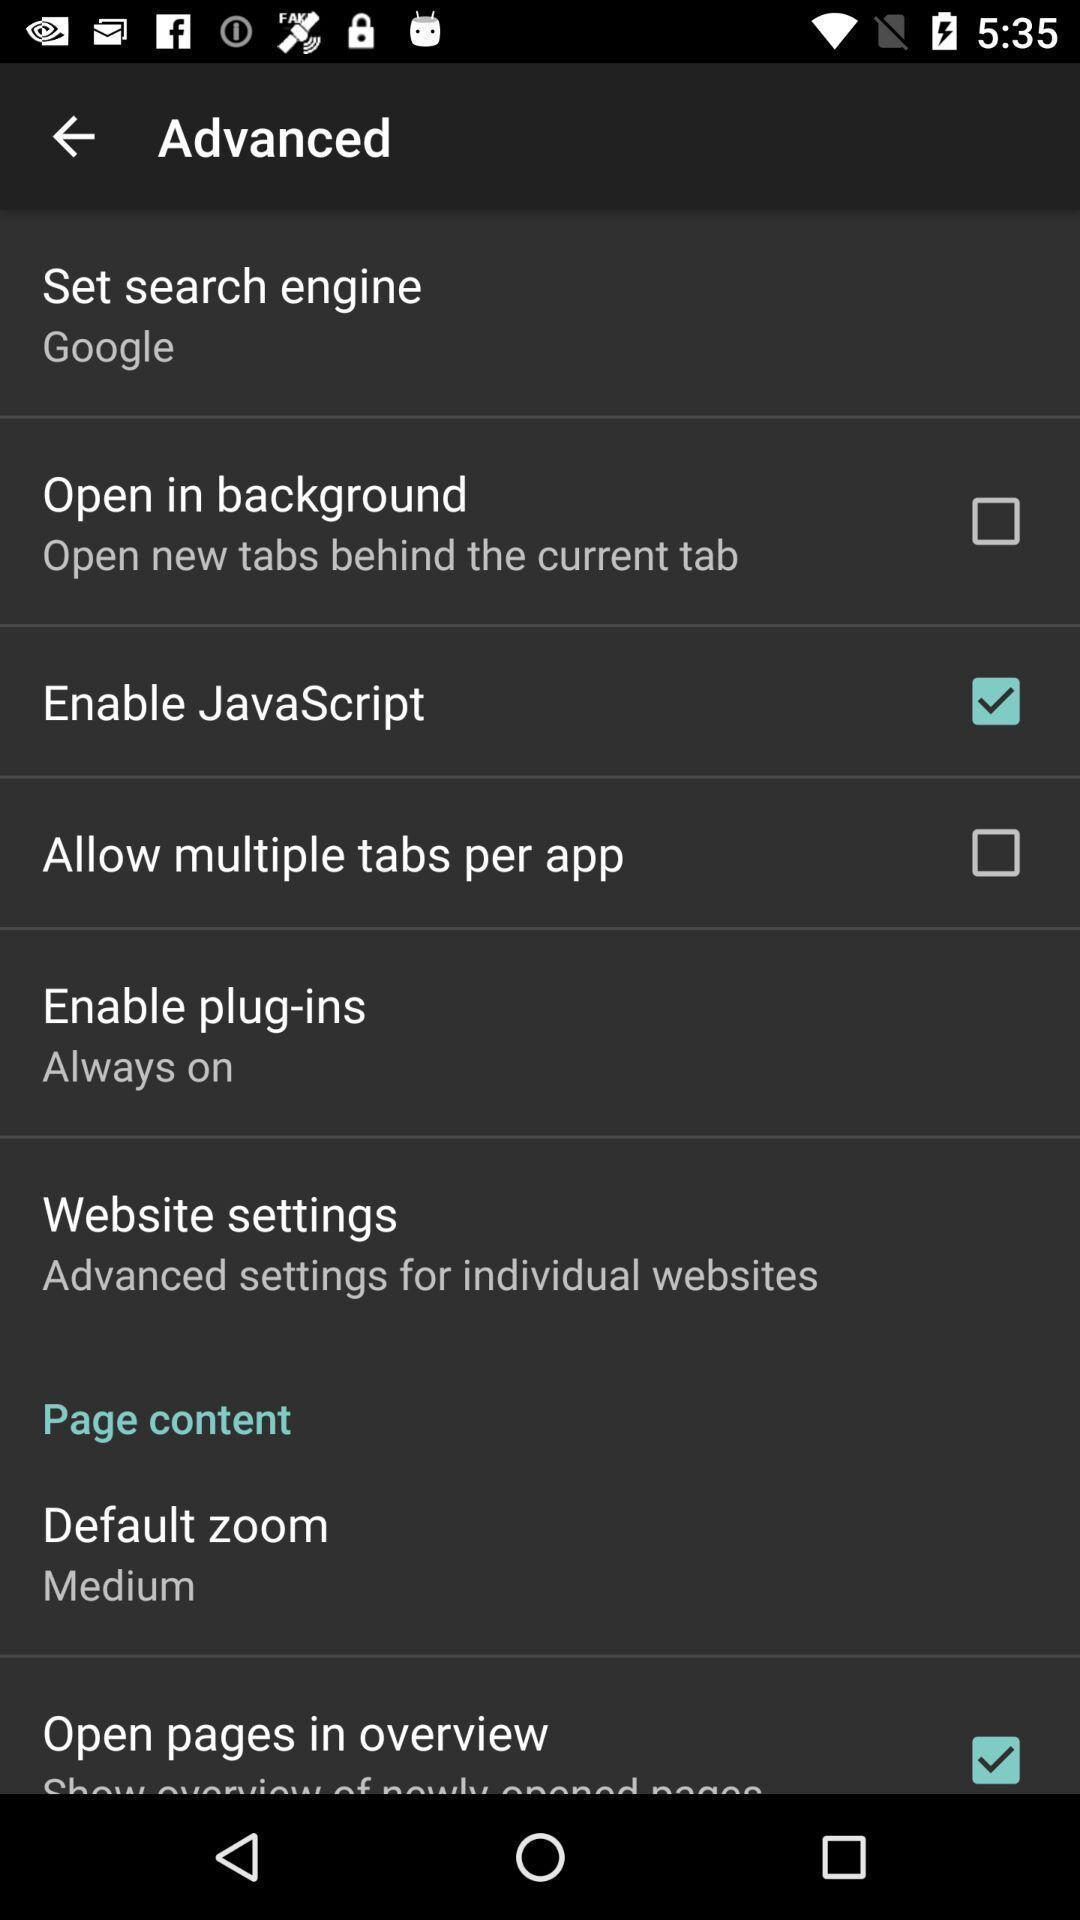Summarize the main components in this picture. Screen shows advanced details. 